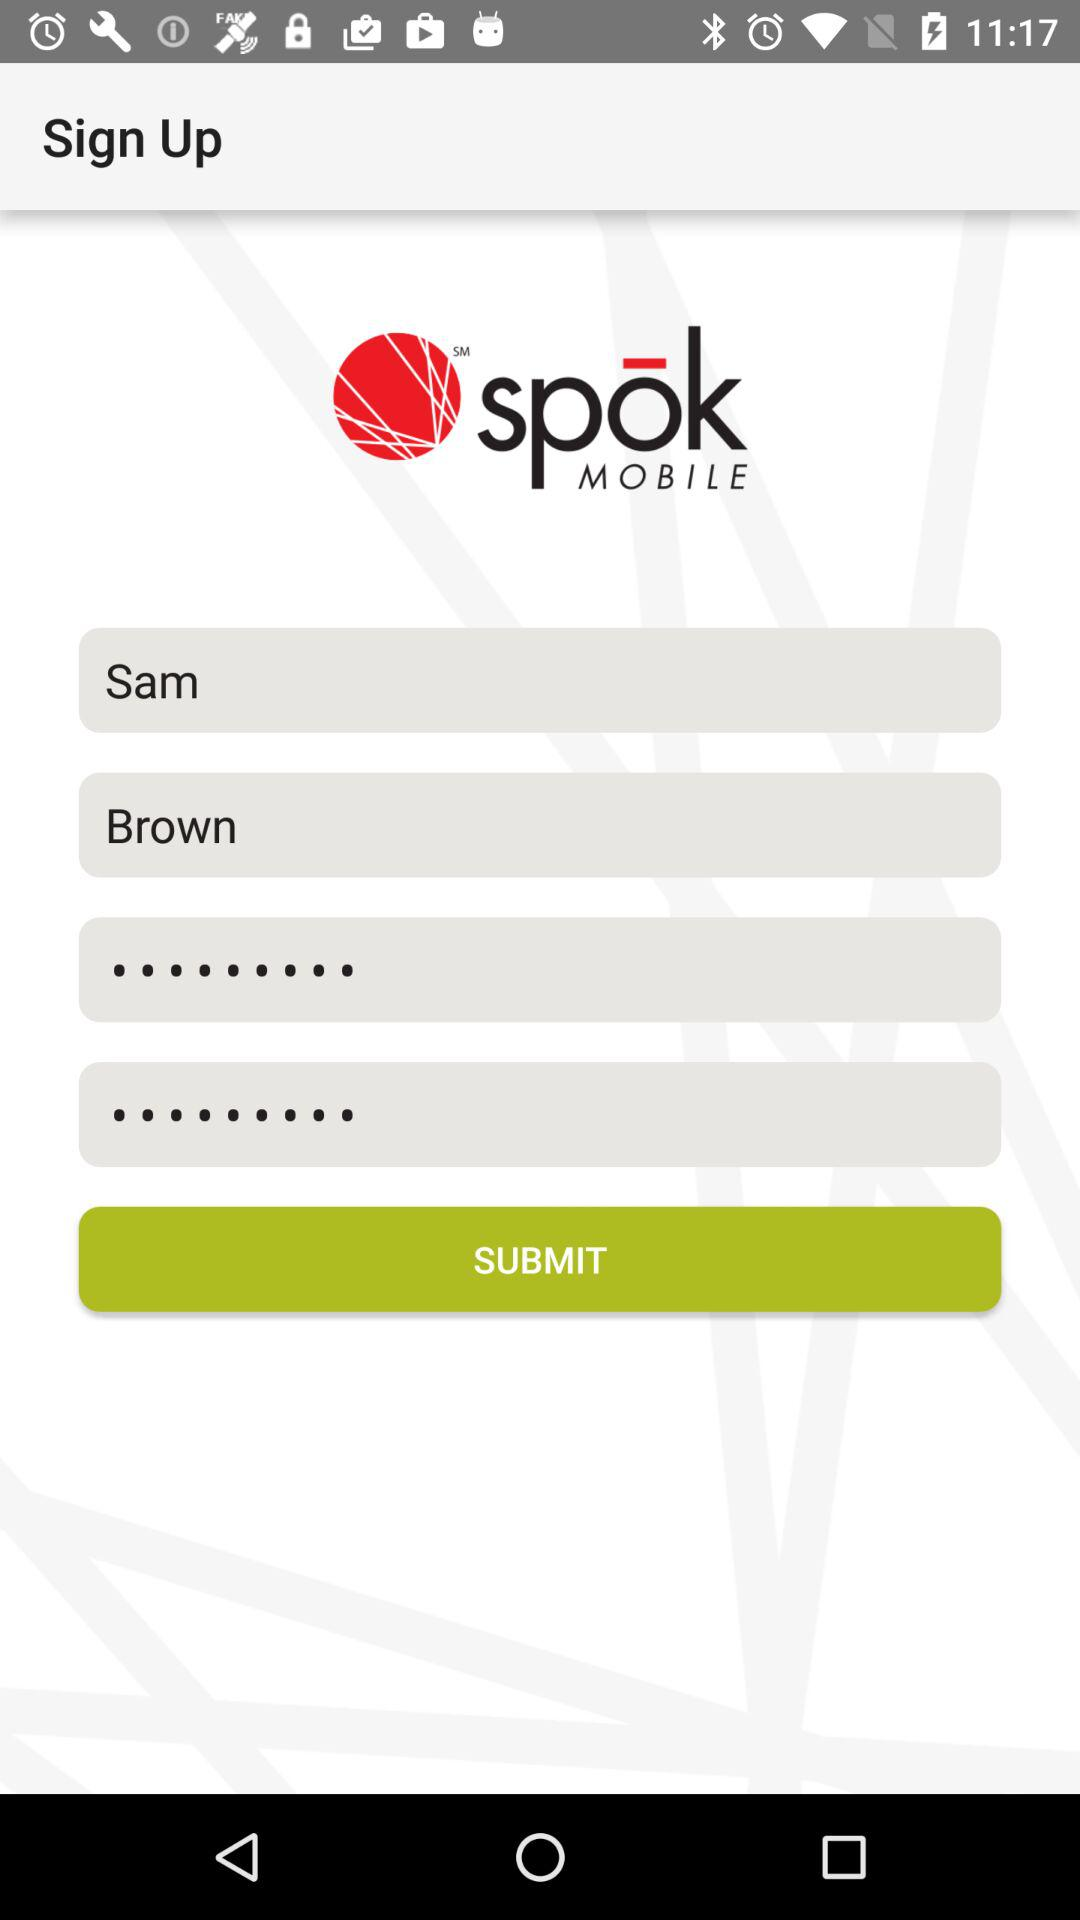What is the first name of the user? The first name of the user is Sam. 